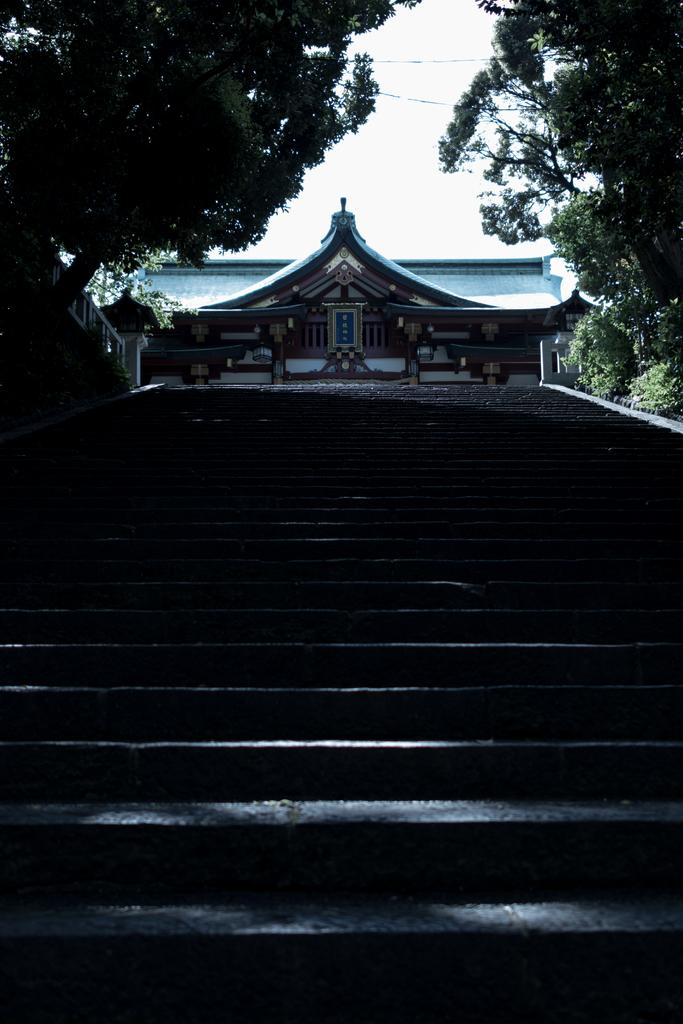What type of structure is visible in the image? There is a house in the image. What can be seen at the bottom of the image? There are many steps at the bottom of the image. What type of vegetation is present on both sides of the image? There are trees on the left and right sides of the image. What is visible at the top of the image? The sky is visible at the top of the image. What type of chalk is being used to draw on the cord in the image? There is no chalk or cord present in the image. What sound can be heard coming from the trees in the image? The image does not include any sounds, so it is not possible to determine what sound might be coming from the trees. 